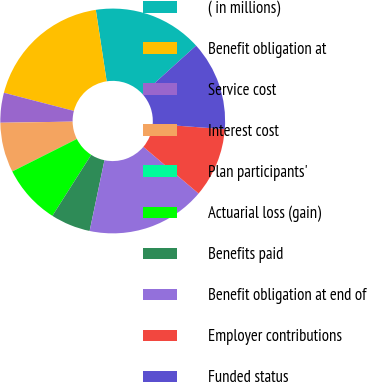<chart> <loc_0><loc_0><loc_500><loc_500><pie_chart><fcel>( in millions)<fcel>Benefit obligation at<fcel>Service cost<fcel>Interest cost<fcel>Plan participants'<fcel>Actuarial loss (gain)<fcel>Benefits paid<fcel>Benefit obligation at end of<fcel>Employer contributions<fcel>Funded status<nl><fcel>15.71%<fcel>18.56%<fcel>4.29%<fcel>7.15%<fcel>0.01%<fcel>8.57%<fcel>5.72%<fcel>17.13%<fcel>10.0%<fcel>12.85%<nl></chart> 